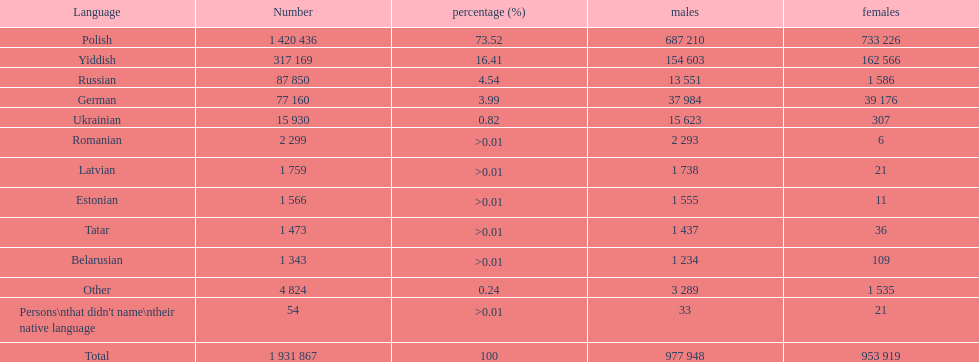What was the top language from the one's whose percentage was >0.01 Romanian. 